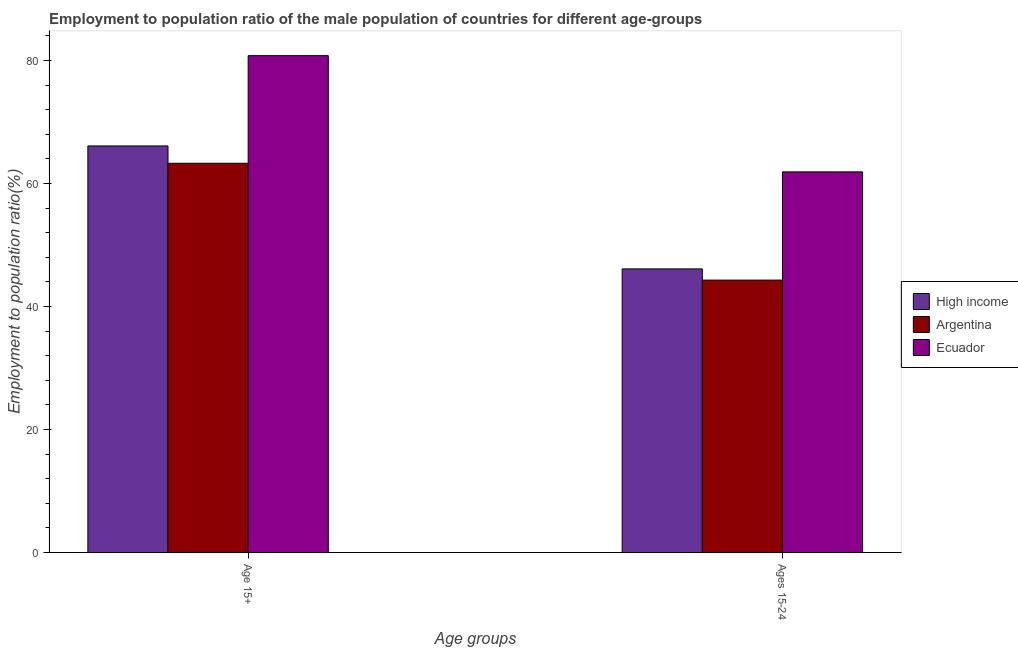What is the label of the 2nd group of bars from the left?
Your answer should be compact. Ages 15-24. What is the employment to population ratio(age 15-24) in Ecuador?
Your answer should be very brief. 61.9. Across all countries, what is the maximum employment to population ratio(age 15-24)?
Your response must be concise. 61.9. Across all countries, what is the minimum employment to population ratio(age 15-24)?
Your answer should be compact. 44.3. In which country was the employment to population ratio(age 15-24) maximum?
Provide a short and direct response. Ecuador. In which country was the employment to population ratio(age 15-24) minimum?
Ensure brevity in your answer.  Argentina. What is the total employment to population ratio(age 15-24) in the graph?
Ensure brevity in your answer.  152.32. What is the difference between the employment to population ratio(age 15-24) in Ecuador and that in Argentina?
Your response must be concise. 17.6. What is the difference between the employment to population ratio(age 15-24) in Ecuador and the employment to population ratio(age 15+) in Argentina?
Provide a short and direct response. -1.4. What is the average employment to population ratio(age 15-24) per country?
Offer a terse response. 50.77. What is the difference between the employment to population ratio(age 15-24) and employment to population ratio(age 15+) in Argentina?
Give a very brief answer. -19. In how many countries, is the employment to population ratio(age 15+) greater than 48 %?
Your response must be concise. 3. What is the ratio of the employment to population ratio(age 15-24) in Ecuador to that in High income?
Provide a short and direct response. 1.34. In how many countries, is the employment to population ratio(age 15-24) greater than the average employment to population ratio(age 15-24) taken over all countries?
Give a very brief answer. 1. What does the 1st bar from the left in Age 15+ represents?
Your answer should be compact. High income. How many bars are there?
Ensure brevity in your answer.  6. What is the difference between two consecutive major ticks on the Y-axis?
Keep it short and to the point. 20. Are the values on the major ticks of Y-axis written in scientific E-notation?
Your answer should be compact. No. Does the graph contain any zero values?
Offer a very short reply. No. Does the graph contain grids?
Provide a short and direct response. No. Where does the legend appear in the graph?
Ensure brevity in your answer.  Center right. How many legend labels are there?
Your response must be concise. 3. What is the title of the graph?
Offer a very short reply. Employment to population ratio of the male population of countries for different age-groups. Does "Nicaragua" appear as one of the legend labels in the graph?
Your answer should be very brief. No. What is the label or title of the X-axis?
Provide a succinct answer. Age groups. What is the label or title of the Y-axis?
Your response must be concise. Employment to population ratio(%). What is the Employment to population ratio(%) of High income in Age 15+?
Your response must be concise. 66.12. What is the Employment to population ratio(%) of Argentina in Age 15+?
Keep it short and to the point. 63.3. What is the Employment to population ratio(%) in Ecuador in Age 15+?
Give a very brief answer. 80.8. What is the Employment to population ratio(%) in High income in Ages 15-24?
Give a very brief answer. 46.12. What is the Employment to population ratio(%) of Argentina in Ages 15-24?
Provide a succinct answer. 44.3. What is the Employment to population ratio(%) in Ecuador in Ages 15-24?
Offer a very short reply. 61.9. Across all Age groups, what is the maximum Employment to population ratio(%) in High income?
Your answer should be very brief. 66.12. Across all Age groups, what is the maximum Employment to population ratio(%) in Argentina?
Keep it short and to the point. 63.3. Across all Age groups, what is the maximum Employment to population ratio(%) of Ecuador?
Give a very brief answer. 80.8. Across all Age groups, what is the minimum Employment to population ratio(%) of High income?
Your response must be concise. 46.12. Across all Age groups, what is the minimum Employment to population ratio(%) in Argentina?
Provide a succinct answer. 44.3. Across all Age groups, what is the minimum Employment to population ratio(%) in Ecuador?
Offer a very short reply. 61.9. What is the total Employment to population ratio(%) in High income in the graph?
Offer a terse response. 112.24. What is the total Employment to population ratio(%) of Argentina in the graph?
Keep it short and to the point. 107.6. What is the total Employment to population ratio(%) in Ecuador in the graph?
Provide a short and direct response. 142.7. What is the difference between the Employment to population ratio(%) of High income in Age 15+ and that in Ages 15-24?
Ensure brevity in your answer.  20. What is the difference between the Employment to population ratio(%) of Argentina in Age 15+ and that in Ages 15-24?
Your answer should be compact. 19. What is the difference between the Employment to population ratio(%) of High income in Age 15+ and the Employment to population ratio(%) of Argentina in Ages 15-24?
Keep it short and to the point. 21.82. What is the difference between the Employment to population ratio(%) in High income in Age 15+ and the Employment to population ratio(%) in Ecuador in Ages 15-24?
Your answer should be very brief. 4.22. What is the difference between the Employment to population ratio(%) of Argentina in Age 15+ and the Employment to population ratio(%) of Ecuador in Ages 15-24?
Offer a very short reply. 1.4. What is the average Employment to population ratio(%) in High income per Age groups?
Your answer should be very brief. 56.12. What is the average Employment to population ratio(%) of Argentina per Age groups?
Ensure brevity in your answer.  53.8. What is the average Employment to population ratio(%) in Ecuador per Age groups?
Ensure brevity in your answer.  71.35. What is the difference between the Employment to population ratio(%) in High income and Employment to population ratio(%) in Argentina in Age 15+?
Provide a succinct answer. 2.82. What is the difference between the Employment to population ratio(%) in High income and Employment to population ratio(%) in Ecuador in Age 15+?
Your response must be concise. -14.68. What is the difference between the Employment to population ratio(%) in Argentina and Employment to population ratio(%) in Ecuador in Age 15+?
Your response must be concise. -17.5. What is the difference between the Employment to population ratio(%) in High income and Employment to population ratio(%) in Argentina in Ages 15-24?
Keep it short and to the point. 1.82. What is the difference between the Employment to population ratio(%) in High income and Employment to population ratio(%) in Ecuador in Ages 15-24?
Ensure brevity in your answer.  -15.78. What is the difference between the Employment to population ratio(%) in Argentina and Employment to population ratio(%) in Ecuador in Ages 15-24?
Your response must be concise. -17.6. What is the ratio of the Employment to population ratio(%) of High income in Age 15+ to that in Ages 15-24?
Provide a succinct answer. 1.43. What is the ratio of the Employment to population ratio(%) in Argentina in Age 15+ to that in Ages 15-24?
Keep it short and to the point. 1.43. What is the ratio of the Employment to population ratio(%) in Ecuador in Age 15+ to that in Ages 15-24?
Your answer should be compact. 1.31. What is the difference between the highest and the second highest Employment to population ratio(%) of High income?
Offer a terse response. 20. What is the difference between the highest and the second highest Employment to population ratio(%) of Ecuador?
Provide a short and direct response. 18.9. What is the difference between the highest and the lowest Employment to population ratio(%) in High income?
Give a very brief answer. 20. What is the difference between the highest and the lowest Employment to population ratio(%) of Argentina?
Offer a terse response. 19. 